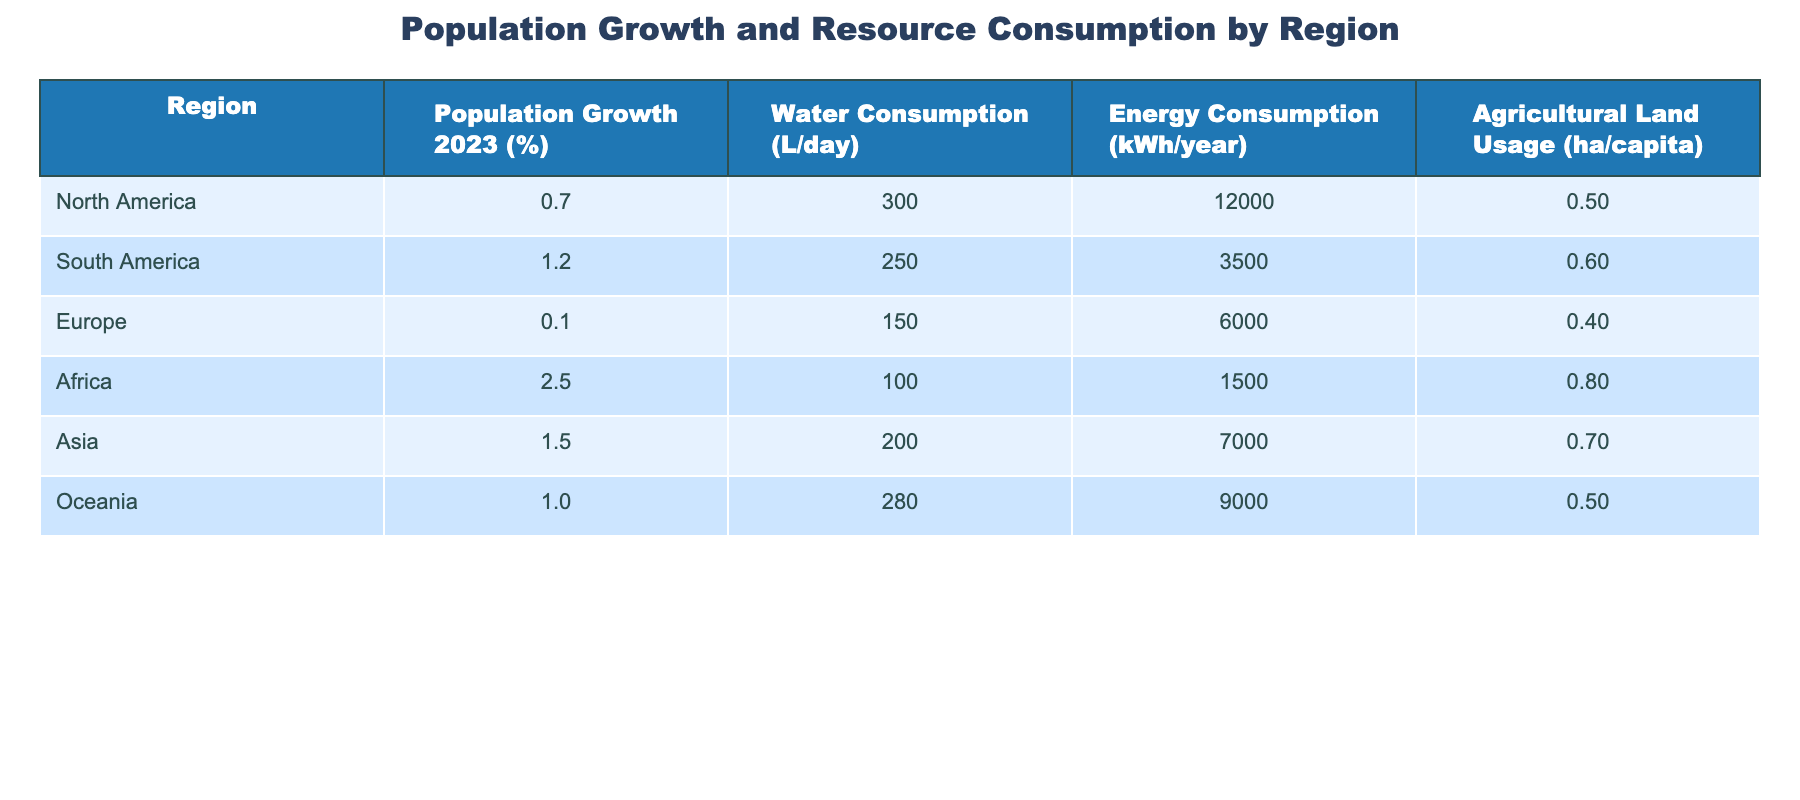What is the population growth percentage in Africa? According to the table, the population growth in Africa is listed under the "Population Growth 2023 (%)" column which shows 2.5%.
Answer: 2.5% Which region has the highest water consumption per capita? By comparing the "Water Consumption (L/day)" column for all regions, North America has the highest value at 300 liters/day.
Answer: North America Is the energy consumption per capita in South America higher than that in Europe? In the "Energy Consumption (kWh/year)" column, South America shows a value of 3500, while Europe shows 6000. Since 3500 is less than 6000, the answer is no.
Answer: No What is the average agricultural land usage per capita across all regions? To find the average, sum the agricultural land usage values: (0.5 + 0.6 + 0.4 + 0.8 + 0.7 + 0.5) = 3.5. Then divide by 6 regions: 3.5 / 6 = approximately 0.58.
Answer: 0.58 Which region consumes the least energy per capita? Looking through the "Energy Consumption (kWh/year)" column, Africa shows the lowest value of 1500 kWh/year, making it the region with the least energy consumption per capita.
Answer: Africa Is it true that Oceania has a higher population growth percentage than North America? Oceania's population growth is 1.0% while North America's is 0.7%. Since 1.0% is higher than 0.7%, the statement is true.
Answer: Yes What is the difference in water consumption per capita between Asia and Africa? From the "Water Consumption (L/day)" column, Asia has 200 L/day and Africa has 100 L/day. The difference is 200 - 100 = 100 L/day.
Answer: 100 L/day If we sum the population growth percentages of North America, South America, and Europe, what will the total be? The percentages are 0.7% for North America, 1.2% for South America, and 0.1% for Europe. Summing these gives 0.7 + 1.2 + 0.1 = 2.0%.
Answer: 2.0% 